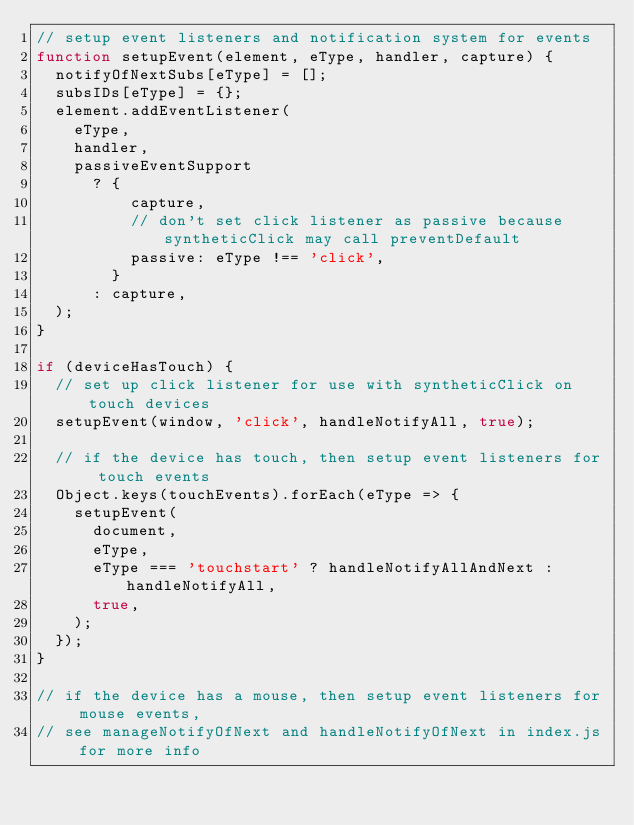<code> <loc_0><loc_0><loc_500><loc_500><_JavaScript_>// setup event listeners and notification system for events
function setupEvent(element, eType, handler, capture) {
  notifyOfNextSubs[eType] = [];
  subsIDs[eType] = {};
  element.addEventListener(
    eType,
    handler,
    passiveEventSupport
      ? {
          capture,
          // don't set click listener as passive because syntheticClick may call preventDefault
          passive: eType !== 'click',
        }
      : capture,
  );
}

if (deviceHasTouch) {
  // set up click listener for use with syntheticClick on touch devices
  setupEvent(window, 'click', handleNotifyAll, true);

  // if the device has touch, then setup event listeners for touch events
  Object.keys(touchEvents).forEach(eType => {
    setupEvent(
      document,
      eType,
      eType === 'touchstart' ? handleNotifyAllAndNext : handleNotifyAll,
      true,
    );
  });
}

// if the device has a mouse, then setup event listeners for mouse events,
// see manageNotifyOfNext and handleNotifyOfNext in index.js for more info</code> 